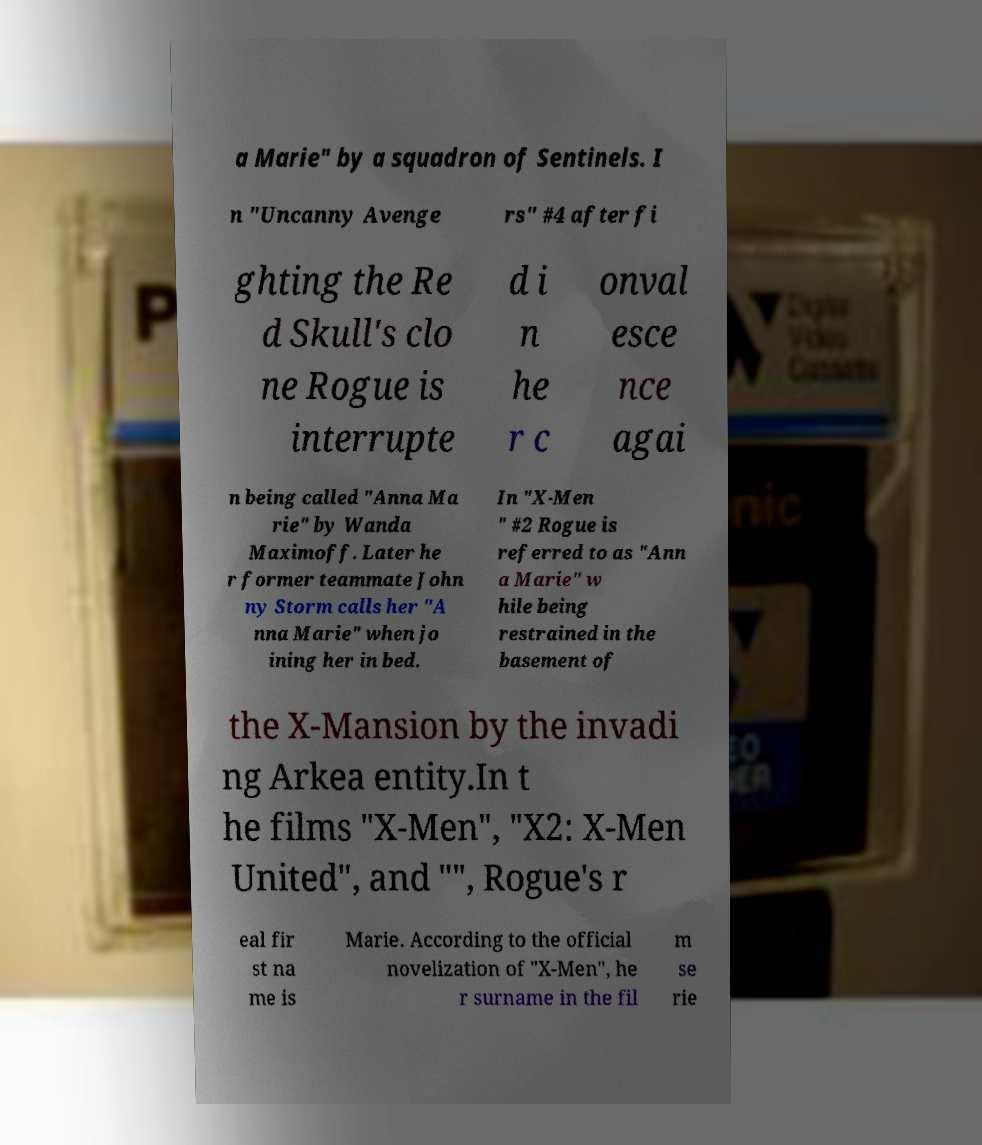Can you accurately transcribe the text from the provided image for me? a Marie" by a squadron of Sentinels. I n "Uncanny Avenge rs" #4 after fi ghting the Re d Skull's clo ne Rogue is interrupte d i n he r c onval esce nce agai n being called "Anna Ma rie" by Wanda Maximoff. Later he r former teammate John ny Storm calls her "A nna Marie" when jo ining her in bed. In "X-Men " #2 Rogue is referred to as "Ann a Marie" w hile being restrained in the basement of the X-Mansion by the invadi ng Arkea entity.In t he films "X-Men", "X2: X-Men United", and "", Rogue's r eal fir st na me is Marie. According to the official novelization of "X-Men", he r surname in the fil m se rie 